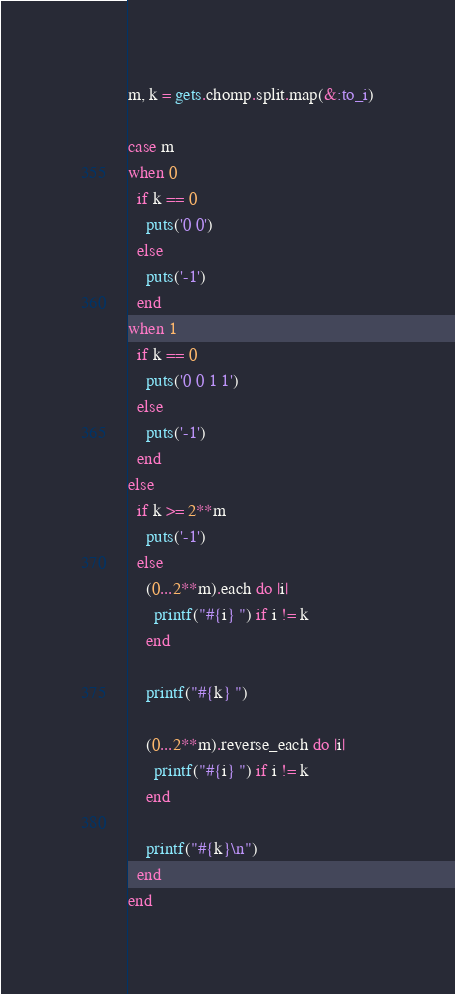<code> <loc_0><loc_0><loc_500><loc_500><_Ruby_>m, k = gets.chomp.split.map(&:to_i)

case m
when 0
  if k == 0
    puts('0 0')
  else
    puts('-1')
  end
when 1
  if k == 0
    puts('0 0 1 1')
  else
    puts('-1')
  end
else
  if k >= 2**m
    puts('-1')
  else
    (0...2**m).each do |i|
      printf("#{i} ") if i != k
    end

    printf("#{k} ")

    (0...2**m).reverse_each do |i|
      printf("#{i} ") if i != k
    end

    printf("#{k}\n")
  end
end</code> 